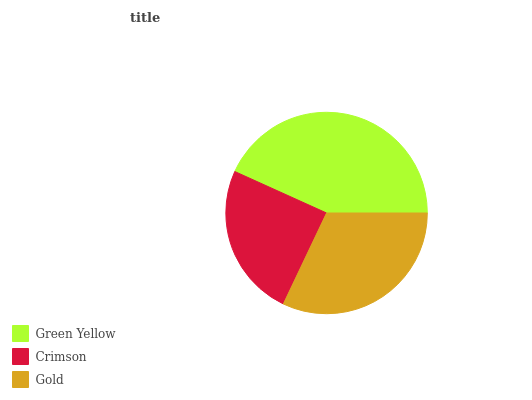Is Crimson the minimum?
Answer yes or no. Yes. Is Green Yellow the maximum?
Answer yes or no. Yes. Is Gold the minimum?
Answer yes or no. No. Is Gold the maximum?
Answer yes or no. No. Is Gold greater than Crimson?
Answer yes or no. Yes. Is Crimson less than Gold?
Answer yes or no. Yes. Is Crimson greater than Gold?
Answer yes or no. No. Is Gold less than Crimson?
Answer yes or no. No. Is Gold the high median?
Answer yes or no. Yes. Is Gold the low median?
Answer yes or no. Yes. Is Crimson the high median?
Answer yes or no. No. Is Crimson the low median?
Answer yes or no. No. 